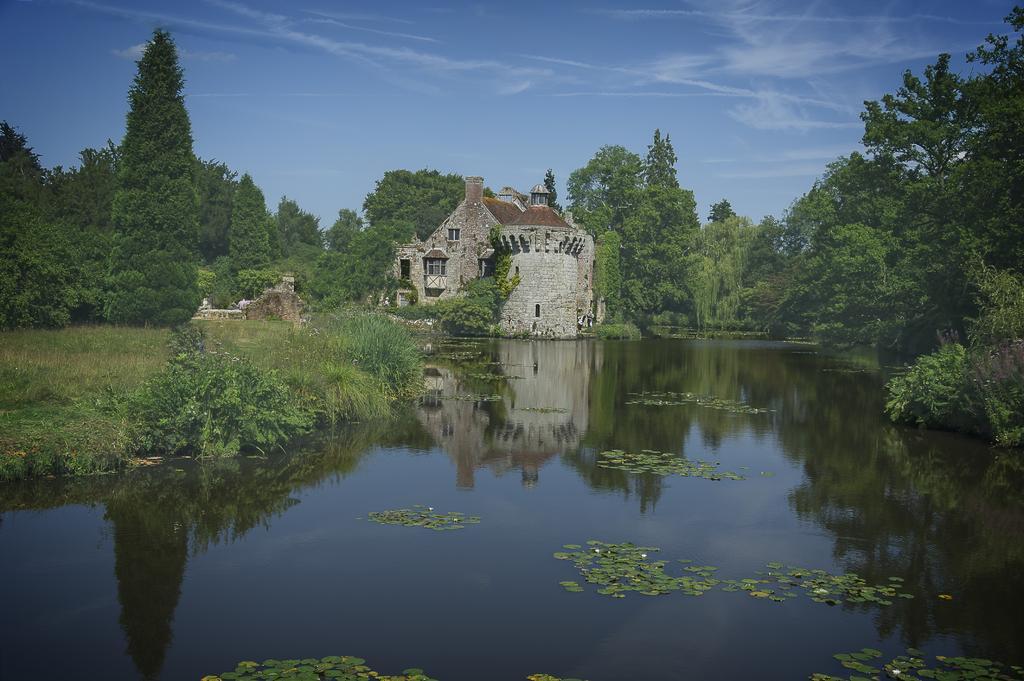Describe this image in one or two sentences. This picture might be taken from outside of the city. In this image, on the right side, we can see some trees and plants. On the left side, we can also see some trees, plants and a building, brick wall. In the middle of the image, we can also see a building, glass windows. In the background, we can see some trees, plants. On the top, we can see a sky, at the bottom there is a water in a lake with some leaves, we can also see a grass at the bottom. 